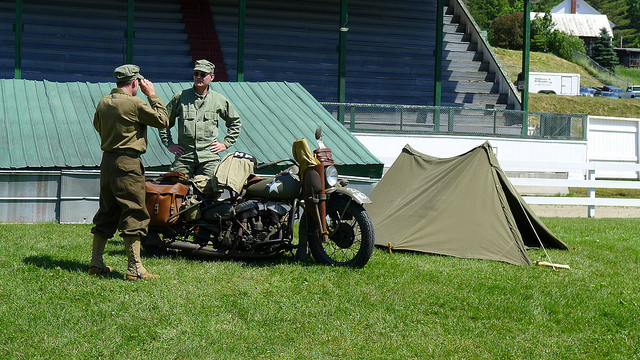Could you tell me more about what the two individuals are doing? In the image, two individuals dressed in military uniforms appear to be engaged in a conversation beside a vintage military motorcycle with a sidecar. One person is leaning against the motorcycle, suggesting a relaxed and informal interaction. The setting does not suggest any urgent activity, and there is no indication that they are performing any maintenance or inspection tasks on the motorcycle at the moment. 